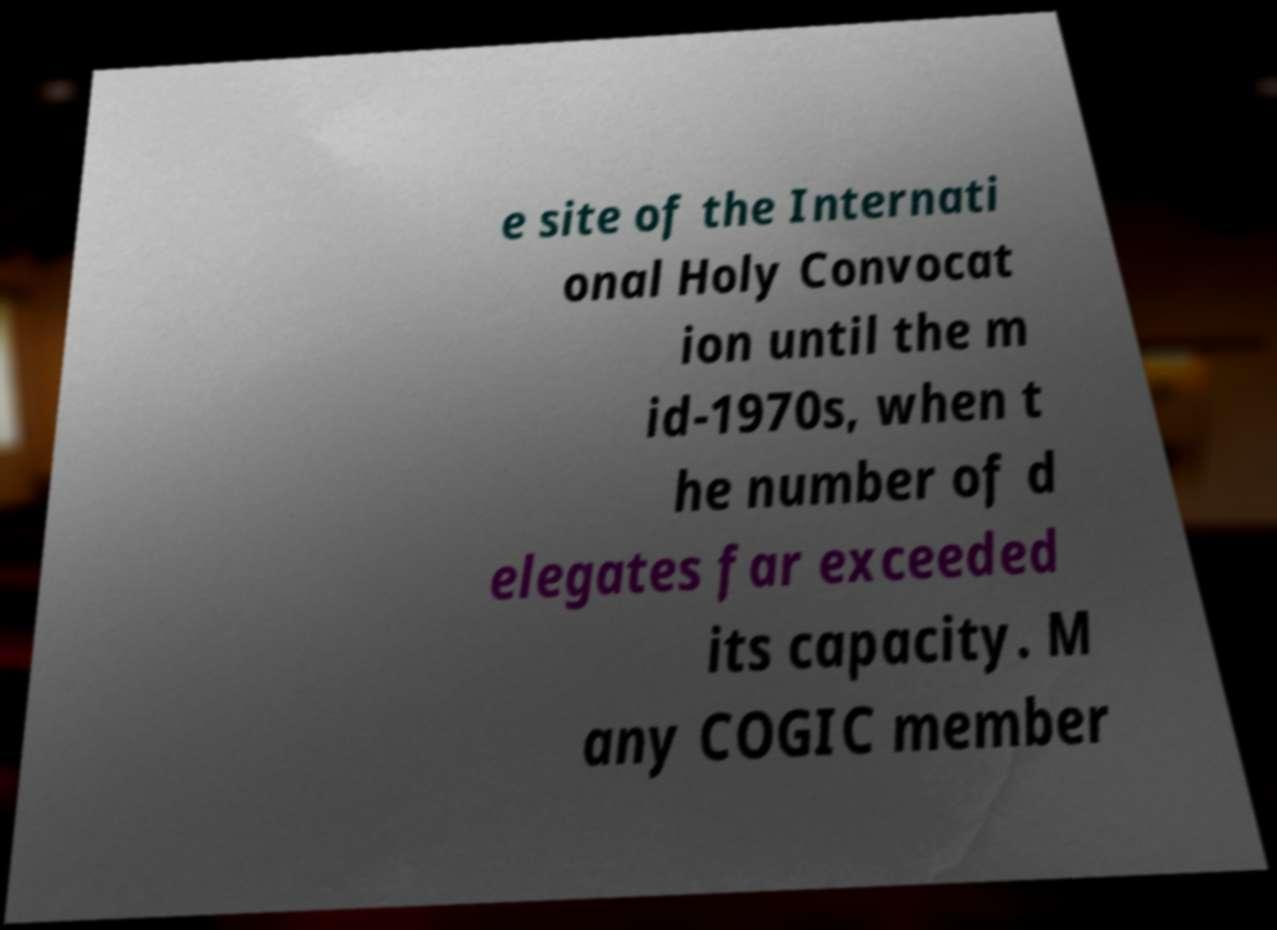Please identify and transcribe the text found in this image. e site of the Internati onal Holy Convocat ion until the m id-1970s, when t he number of d elegates far exceeded its capacity. M any COGIC member 